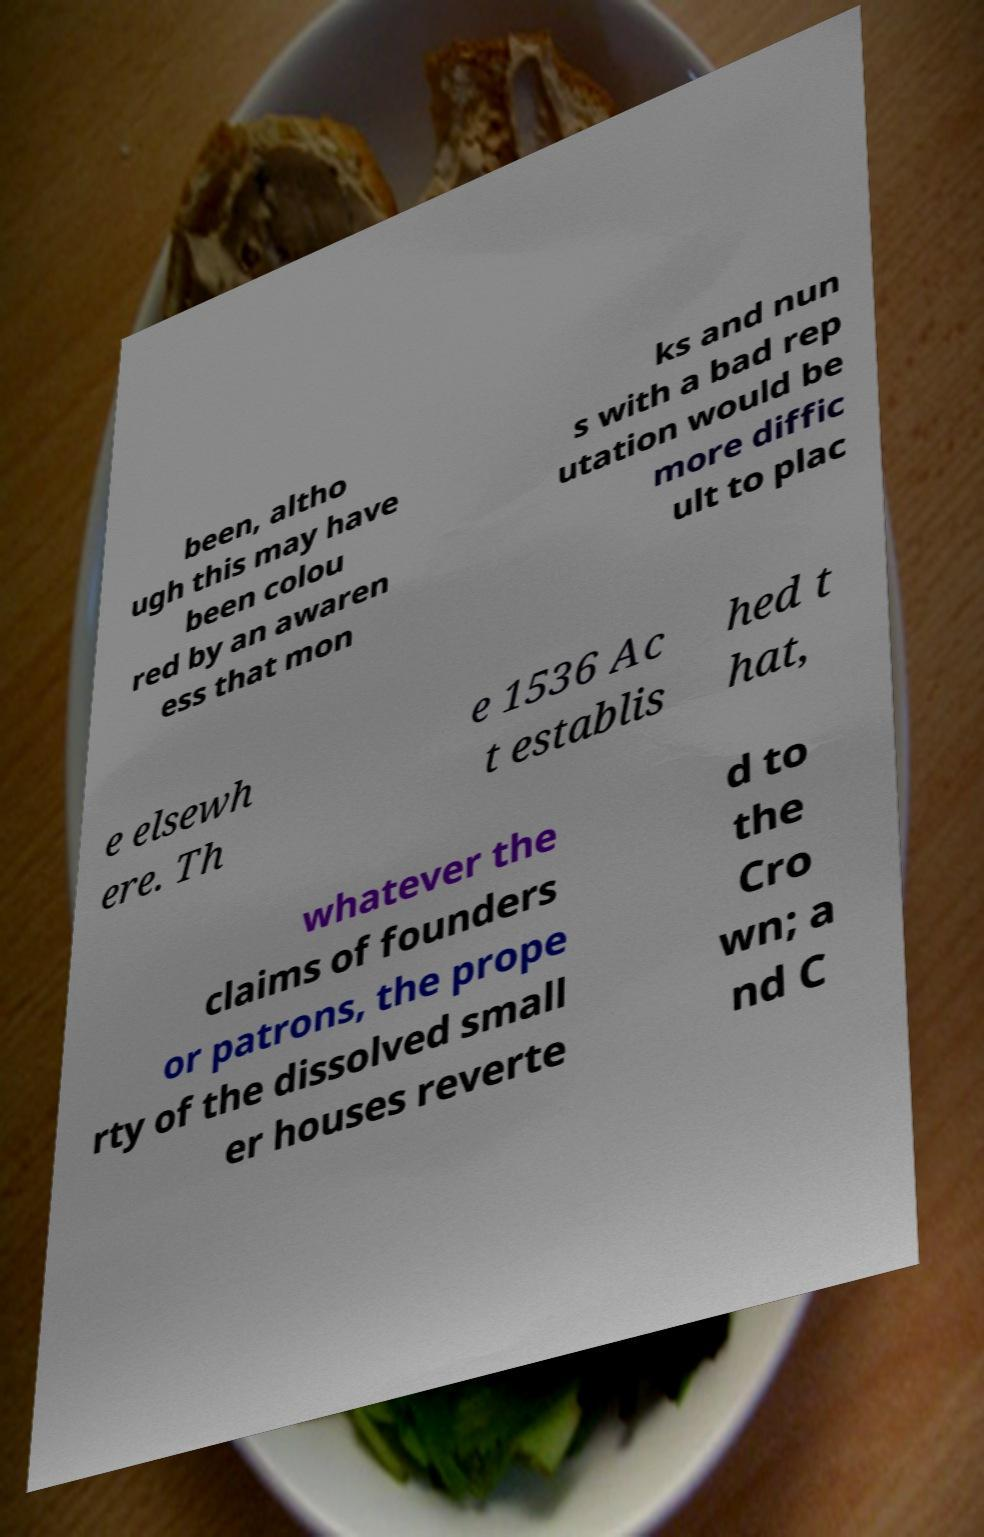What messages or text are displayed in this image? I need them in a readable, typed format. been, altho ugh this may have been colou red by an awaren ess that mon ks and nun s with a bad rep utation would be more diffic ult to plac e elsewh ere. Th e 1536 Ac t establis hed t hat, whatever the claims of founders or patrons, the prope rty of the dissolved small er houses reverte d to the Cro wn; a nd C 